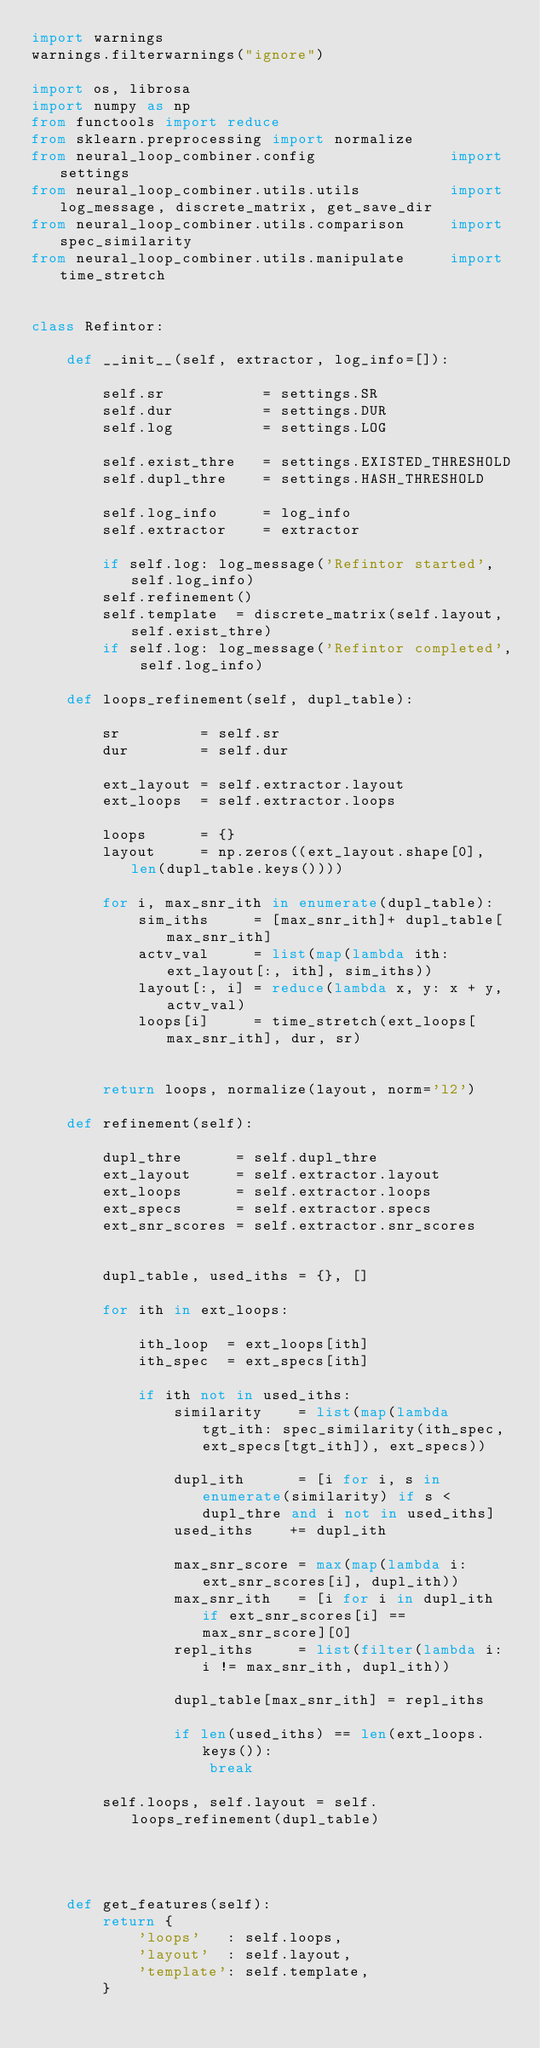<code> <loc_0><loc_0><loc_500><loc_500><_Python_>import warnings
warnings.filterwarnings("ignore")

import os, librosa
import numpy as np
from functools import reduce
from sklearn.preprocessing import normalize
from neural_loop_combiner.config               import settings
from neural_loop_combiner.utils.utils          import log_message, discrete_matrix, get_save_dir
from neural_loop_combiner.utils.comparison     import spec_similarity
from neural_loop_combiner.utils.manipulate     import time_stretch


class Refintor:
    
    def __init__(self, extractor, log_info=[]):
        
        self.sr           = settings.SR
        self.dur          = settings.DUR
        self.log          = settings.LOG

        self.exist_thre   = settings.EXISTED_THRESHOLD
        self.dupl_thre    = settings.HASH_THRESHOLD
        
        self.log_info     = log_info
        self.extractor    = extractor
        
        if self.log: log_message('Refintor started', self.log_info)
        self.refinement()
        self.template  = discrete_matrix(self.layout, self.exist_thre)
        if self.log: log_message('Refintor completed', self.log_info)
    
    def loops_refinement(self, dupl_table):
        
        sr         = self.sr
        dur        = self.dur
        
        ext_layout = self.extractor.layout
        ext_loops  = self.extractor.loops
        
        loops      = {}
        layout     = np.zeros((ext_layout.shape[0], len(dupl_table.keys())))
        
        for i, max_snr_ith in enumerate(dupl_table):
            sim_iths     = [max_snr_ith]+ dupl_table[max_snr_ith]
            actv_val     = list(map(lambda ith: ext_layout[:, ith], sim_iths))
            layout[:, i] = reduce(lambda x, y: x + y, actv_val)
            loops[i]     = time_stretch(ext_loops[max_snr_ith], dur, sr)
            
            
        return loops, normalize(layout, norm='l2') 
    
    def refinement(self):
        
        dupl_thre      = self.dupl_thre
        ext_layout     = self.extractor.layout
        ext_loops      = self.extractor.loops
        ext_specs      = self.extractor.specs
        ext_snr_scores = self.extractor.snr_scores
        
        
        dupl_table, used_iths = {}, []

        for ith in ext_loops:
            
            ith_loop  = ext_loops[ith]
            ith_spec  = ext_specs[ith]
            
            if ith not in used_iths:
                similarity    = list(map(lambda tgt_ith: spec_similarity(ith_spec, ext_specs[tgt_ith]), ext_specs))
                
                dupl_ith      = [i for i, s in enumerate(similarity) if s < dupl_thre and i not in used_iths]
                used_iths    += dupl_ith
                
                max_snr_score = max(map(lambda i: ext_snr_scores[i], dupl_ith))             
                max_snr_ith   = [i for i in dupl_ith if ext_snr_scores[i] == max_snr_score][0]
                repl_iths     = list(filter(lambda i: i != max_snr_ith, dupl_ith))

                dupl_table[max_snr_ith] = repl_iths
                
                if len(used_iths) == len(ext_loops.keys()):
                    break
                    
        self.loops, self.layout = self.loops_refinement(dupl_table)
        

        
        
    def get_features(self):
        return {
            'loops'   : self.loops,
            'layout'  : self.layout, 
            'template': self.template,
        }</code> 